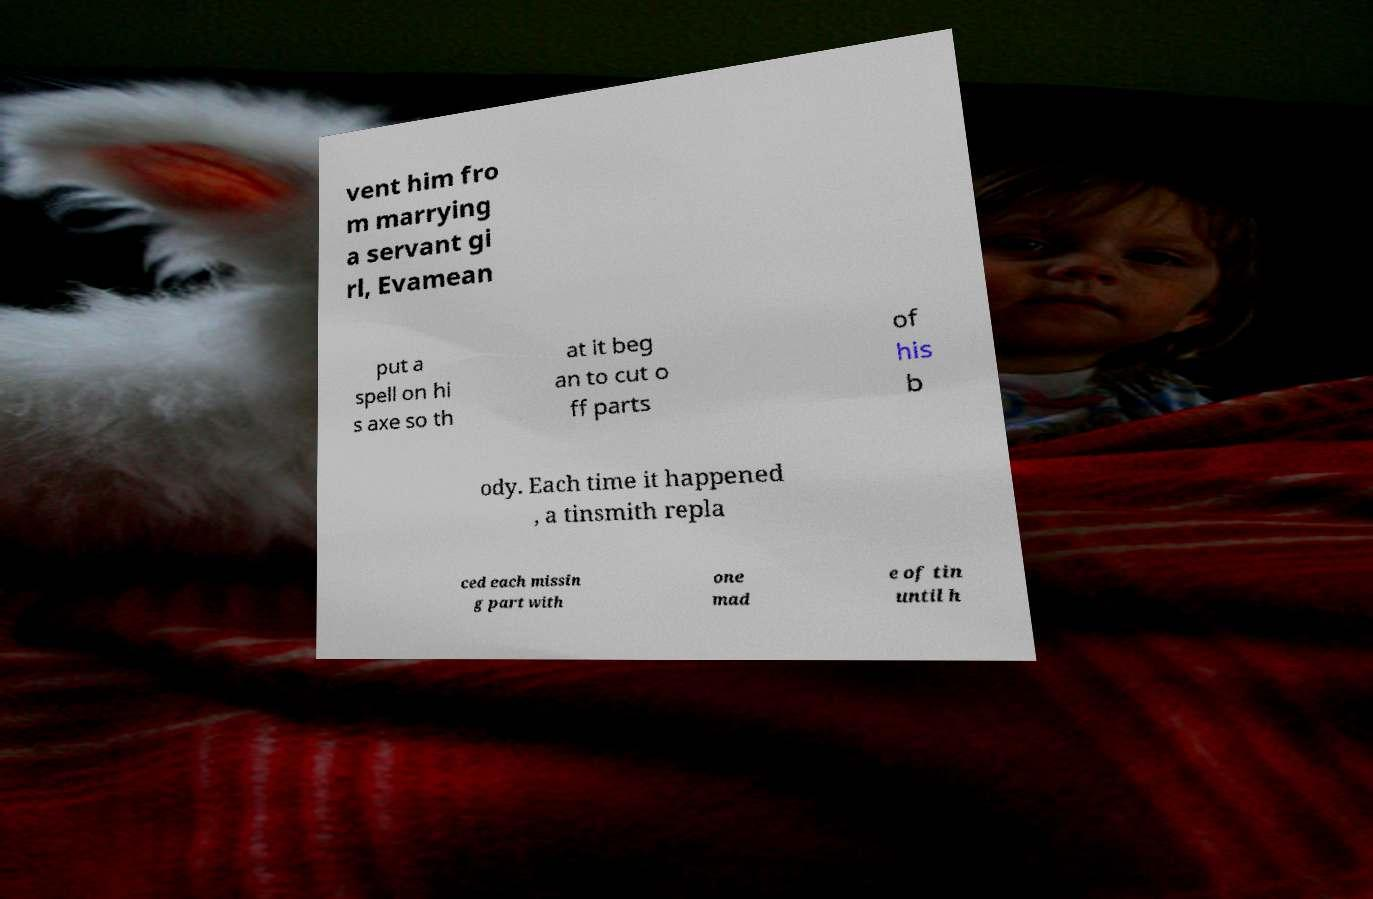Can you read and provide the text displayed in the image?This photo seems to have some interesting text. Can you extract and type it out for me? vent him fro m marrying a servant gi rl, Evamean put a spell on hi s axe so th at it beg an to cut o ff parts of his b ody. Each time it happened , a tinsmith repla ced each missin g part with one mad e of tin until h 